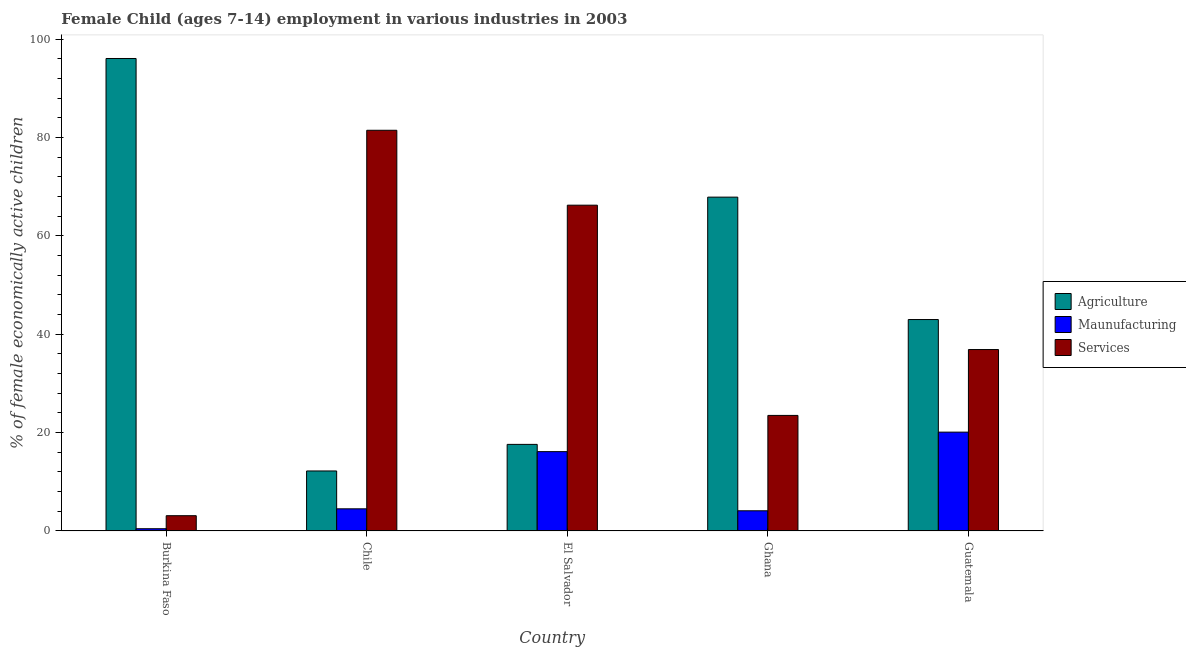How many different coloured bars are there?
Your answer should be compact. 3. Are the number of bars per tick equal to the number of legend labels?
Make the answer very short. Yes. How many bars are there on the 3rd tick from the left?
Your response must be concise. 3. How many bars are there on the 1st tick from the right?
Ensure brevity in your answer.  3. What is the label of the 1st group of bars from the left?
Provide a succinct answer. Burkina Faso. In how many cases, is the number of bars for a given country not equal to the number of legend labels?
Provide a short and direct response. 0. Across all countries, what is the maximum percentage of economically active children in manufacturing?
Your response must be concise. 20.1. In which country was the percentage of economically active children in services maximum?
Offer a very short reply. Chile. In which country was the percentage of economically active children in services minimum?
Ensure brevity in your answer.  Burkina Faso. What is the total percentage of economically active children in agriculture in the graph?
Your answer should be compact. 236.81. What is the difference between the percentage of economically active children in services in Burkina Faso and that in Ghana?
Provide a short and direct response. -20.4. What is the difference between the percentage of economically active children in manufacturing in Chile and the percentage of economically active children in services in Guatemala?
Your answer should be very brief. -32.4. What is the average percentage of economically active children in manufacturing per country?
Provide a short and direct response. 9.06. What is the difference between the percentage of economically active children in services and percentage of economically active children in agriculture in Guatemala?
Your response must be concise. -6.1. What is the ratio of the percentage of economically active children in manufacturing in Burkina Faso to that in Chile?
Offer a terse response. 0.1. Is the percentage of economically active children in services in Burkina Faso less than that in El Salvador?
Provide a short and direct response. Yes. Is the difference between the percentage of economically active children in manufacturing in El Salvador and Ghana greater than the difference between the percentage of economically active children in services in El Salvador and Ghana?
Your response must be concise. No. What is the difference between the highest and the second highest percentage of economically active children in manufacturing?
Make the answer very short. 3.97. What is the difference between the highest and the lowest percentage of economically active children in manufacturing?
Keep it short and to the point. 19.65. In how many countries, is the percentage of economically active children in services greater than the average percentage of economically active children in services taken over all countries?
Make the answer very short. 2. What does the 1st bar from the left in El Salvador represents?
Offer a very short reply. Agriculture. What does the 2nd bar from the right in Chile represents?
Ensure brevity in your answer.  Maunufacturing. Is it the case that in every country, the sum of the percentage of economically active children in agriculture and percentage of economically active children in manufacturing is greater than the percentage of economically active children in services?
Provide a succinct answer. No. How many bars are there?
Make the answer very short. 15. Are all the bars in the graph horizontal?
Your answer should be compact. No. Are the values on the major ticks of Y-axis written in scientific E-notation?
Provide a succinct answer. No. Does the graph contain any zero values?
Make the answer very short. No. Does the graph contain grids?
Give a very brief answer. No. How are the legend labels stacked?
Give a very brief answer. Vertical. What is the title of the graph?
Your answer should be very brief. Female Child (ages 7-14) employment in various industries in 2003. Does "Refusal of sex" appear as one of the legend labels in the graph?
Offer a very short reply. No. What is the label or title of the X-axis?
Offer a very short reply. Country. What is the label or title of the Y-axis?
Make the answer very short. % of female economically active children. What is the % of female economically active children in Agriculture in Burkina Faso?
Your response must be concise. 96.1. What is the % of female economically active children in Maunufacturing in Burkina Faso?
Your answer should be very brief. 0.45. What is the % of female economically active children of Agriculture in Chile?
Provide a succinct answer. 12.2. What is the % of female economically active children of Services in Chile?
Your response must be concise. 81.5. What is the % of female economically active children in Agriculture in El Salvador?
Offer a terse response. 17.61. What is the % of female economically active children of Maunufacturing in El Salvador?
Offer a very short reply. 16.13. What is the % of female economically active children of Services in El Salvador?
Provide a short and direct response. 66.26. What is the % of female economically active children of Agriculture in Ghana?
Provide a succinct answer. 67.9. What is the % of female economically active children of Agriculture in Guatemala?
Offer a terse response. 43. What is the % of female economically active children of Maunufacturing in Guatemala?
Offer a terse response. 20.1. What is the % of female economically active children in Services in Guatemala?
Your answer should be compact. 36.9. Across all countries, what is the maximum % of female economically active children in Agriculture?
Ensure brevity in your answer.  96.1. Across all countries, what is the maximum % of female economically active children of Maunufacturing?
Ensure brevity in your answer.  20.1. Across all countries, what is the maximum % of female economically active children in Services?
Provide a short and direct response. 81.5. Across all countries, what is the minimum % of female economically active children in Agriculture?
Give a very brief answer. 12.2. Across all countries, what is the minimum % of female economically active children of Maunufacturing?
Give a very brief answer. 0.45. What is the total % of female economically active children of Agriculture in the graph?
Offer a terse response. 236.81. What is the total % of female economically active children in Maunufacturing in the graph?
Give a very brief answer. 45.28. What is the total % of female economically active children in Services in the graph?
Your response must be concise. 211.26. What is the difference between the % of female economically active children of Agriculture in Burkina Faso and that in Chile?
Offer a terse response. 83.9. What is the difference between the % of female economically active children of Maunufacturing in Burkina Faso and that in Chile?
Your answer should be very brief. -4.05. What is the difference between the % of female economically active children in Services in Burkina Faso and that in Chile?
Make the answer very short. -78.4. What is the difference between the % of female economically active children of Agriculture in Burkina Faso and that in El Salvador?
Ensure brevity in your answer.  78.49. What is the difference between the % of female economically active children of Maunufacturing in Burkina Faso and that in El Salvador?
Provide a succinct answer. -15.68. What is the difference between the % of female economically active children of Services in Burkina Faso and that in El Salvador?
Your response must be concise. -63.16. What is the difference between the % of female economically active children of Agriculture in Burkina Faso and that in Ghana?
Offer a very short reply. 28.2. What is the difference between the % of female economically active children in Maunufacturing in Burkina Faso and that in Ghana?
Provide a succinct answer. -3.65. What is the difference between the % of female economically active children of Services in Burkina Faso and that in Ghana?
Your answer should be compact. -20.4. What is the difference between the % of female economically active children of Agriculture in Burkina Faso and that in Guatemala?
Offer a very short reply. 53.1. What is the difference between the % of female economically active children of Maunufacturing in Burkina Faso and that in Guatemala?
Ensure brevity in your answer.  -19.65. What is the difference between the % of female economically active children of Services in Burkina Faso and that in Guatemala?
Offer a terse response. -33.8. What is the difference between the % of female economically active children of Agriculture in Chile and that in El Salvador?
Make the answer very short. -5.41. What is the difference between the % of female economically active children of Maunufacturing in Chile and that in El Salvador?
Give a very brief answer. -11.63. What is the difference between the % of female economically active children of Services in Chile and that in El Salvador?
Ensure brevity in your answer.  15.24. What is the difference between the % of female economically active children of Agriculture in Chile and that in Ghana?
Provide a succinct answer. -55.7. What is the difference between the % of female economically active children in Maunufacturing in Chile and that in Ghana?
Offer a very short reply. 0.4. What is the difference between the % of female economically active children of Agriculture in Chile and that in Guatemala?
Provide a short and direct response. -30.8. What is the difference between the % of female economically active children in Maunufacturing in Chile and that in Guatemala?
Your response must be concise. -15.6. What is the difference between the % of female economically active children in Services in Chile and that in Guatemala?
Your answer should be very brief. 44.6. What is the difference between the % of female economically active children of Agriculture in El Salvador and that in Ghana?
Offer a terse response. -50.29. What is the difference between the % of female economically active children in Maunufacturing in El Salvador and that in Ghana?
Provide a short and direct response. 12.03. What is the difference between the % of female economically active children of Services in El Salvador and that in Ghana?
Keep it short and to the point. 42.76. What is the difference between the % of female economically active children of Agriculture in El Salvador and that in Guatemala?
Offer a very short reply. -25.39. What is the difference between the % of female economically active children of Maunufacturing in El Salvador and that in Guatemala?
Your answer should be very brief. -3.97. What is the difference between the % of female economically active children of Services in El Salvador and that in Guatemala?
Provide a short and direct response. 29.36. What is the difference between the % of female economically active children in Agriculture in Ghana and that in Guatemala?
Your answer should be compact. 24.9. What is the difference between the % of female economically active children in Agriculture in Burkina Faso and the % of female economically active children in Maunufacturing in Chile?
Ensure brevity in your answer.  91.6. What is the difference between the % of female economically active children of Maunufacturing in Burkina Faso and the % of female economically active children of Services in Chile?
Your answer should be very brief. -81.05. What is the difference between the % of female economically active children in Agriculture in Burkina Faso and the % of female economically active children in Maunufacturing in El Salvador?
Keep it short and to the point. 79.97. What is the difference between the % of female economically active children of Agriculture in Burkina Faso and the % of female economically active children of Services in El Salvador?
Your response must be concise. 29.84. What is the difference between the % of female economically active children in Maunufacturing in Burkina Faso and the % of female economically active children in Services in El Salvador?
Keep it short and to the point. -65.81. What is the difference between the % of female economically active children of Agriculture in Burkina Faso and the % of female economically active children of Maunufacturing in Ghana?
Provide a succinct answer. 92. What is the difference between the % of female economically active children of Agriculture in Burkina Faso and the % of female economically active children of Services in Ghana?
Offer a very short reply. 72.6. What is the difference between the % of female economically active children of Maunufacturing in Burkina Faso and the % of female economically active children of Services in Ghana?
Your answer should be very brief. -23.05. What is the difference between the % of female economically active children of Agriculture in Burkina Faso and the % of female economically active children of Maunufacturing in Guatemala?
Your answer should be very brief. 76. What is the difference between the % of female economically active children in Agriculture in Burkina Faso and the % of female economically active children in Services in Guatemala?
Provide a short and direct response. 59.2. What is the difference between the % of female economically active children of Maunufacturing in Burkina Faso and the % of female economically active children of Services in Guatemala?
Make the answer very short. -36.45. What is the difference between the % of female economically active children in Agriculture in Chile and the % of female economically active children in Maunufacturing in El Salvador?
Your response must be concise. -3.93. What is the difference between the % of female economically active children in Agriculture in Chile and the % of female economically active children in Services in El Salvador?
Offer a terse response. -54.06. What is the difference between the % of female economically active children in Maunufacturing in Chile and the % of female economically active children in Services in El Salvador?
Make the answer very short. -61.76. What is the difference between the % of female economically active children of Agriculture in Chile and the % of female economically active children of Services in Ghana?
Offer a terse response. -11.3. What is the difference between the % of female economically active children of Agriculture in Chile and the % of female economically active children of Services in Guatemala?
Ensure brevity in your answer.  -24.7. What is the difference between the % of female economically active children of Maunufacturing in Chile and the % of female economically active children of Services in Guatemala?
Provide a succinct answer. -32.4. What is the difference between the % of female economically active children of Agriculture in El Salvador and the % of female economically active children of Maunufacturing in Ghana?
Your response must be concise. 13.51. What is the difference between the % of female economically active children in Agriculture in El Salvador and the % of female economically active children in Services in Ghana?
Offer a very short reply. -5.89. What is the difference between the % of female economically active children in Maunufacturing in El Salvador and the % of female economically active children in Services in Ghana?
Your answer should be very brief. -7.37. What is the difference between the % of female economically active children of Agriculture in El Salvador and the % of female economically active children of Maunufacturing in Guatemala?
Provide a succinct answer. -2.49. What is the difference between the % of female economically active children in Agriculture in El Salvador and the % of female economically active children in Services in Guatemala?
Make the answer very short. -19.29. What is the difference between the % of female economically active children in Maunufacturing in El Salvador and the % of female economically active children in Services in Guatemala?
Ensure brevity in your answer.  -20.77. What is the difference between the % of female economically active children of Agriculture in Ghana and the % of female economically active children of Maunufacturing in Guatemala?
Keep it short and to the point. 47.8. What is the difference between the % of female economically active children in Agriculture in Ghana and the % of female economically active children in Services in Guatemala?
Keep it short and to the point. 31. What is the difference between the % of female economically active children in Maunufacturing in Ghana and the % of female economically active children in Services in Guatemala?
Your response must be concise. -32.8. What is the average % of female economically active children in Agriculture per country?
Make the answer very short. 47.36. What is the average % of female economically active children of Maunufacturing per country?
Ensure brevity in your answer.  9.06. What is the average % of female economically active children of Services per country?
Your answer should be compact. 42.25. What is the difference between the % of female economically active children in Agriculture and % of female economically active children in Maunufacturing in Burkina Faso?
Your answer should be compact. 95.65. What is the difference between the % of female economically active children of Agriculture and % of female economically active children of Services in Burkina Faso?
Give a very brief answer. 93. What is the difference between the % of female economically active children in Maunufacturing and % of female economically active children in Services in Burkina Faso?
Make the answer very short. -2.65. What is the difference between the % of female economically active children of Agriculture and % of female economically active children of Maunufacturing in Chile?
Make the answer very short. 7.7. What is the difference between the % of female economically active children in Agriculture and % of female economically active children in Services in Chile?
Your answer should be very brief. -69.3. What is the difference between the % of female economically active children of Maunufacturing and % of female economically active children of Services in Chile?
Offer a terse response. -77. What is the difference between the % of female economically active children in Agriculture and % of female economically active children in Maunufacturing in El Salvador?
Provide a succinct answer. 1.47. What is the difference between the % of female economically active children of Agriculture and % of female economically active children of Services in El Salvador?
Offer a very short reply. -48.66. What is the difference between the % of female economically active children of Maunufacturing and % of female economically active children of Services in El Salvador?
Make the answer very short. -50.13. What is the difference between the % of female economically active children in Agriculture and % of female economically active children in Maunufacturing in Ghana?
Make the answer very short. 63.8. What is the difference between the % of female economically active children of Agriculture and % of female economically active children of Services in Ghana?
Offer a terse response. 44.4. What is the difference between the % of female economically active children in Maunufacturing and % of female economically active children in Services in Ghana?
Keep it short and to the point. -19.4. What is the difference between the % of female economically active children of Agriculture and % of female economically active children of Maunufacturing in Guatemala?
Offer a terse response. 22.9. What is the difference between the % of female economically active children of Agriculture and % of female economically active children of Services in Guatemala?
Make the answer very short. 6.1. What is the difference between the % of female economically active children of Maunufacturing and % of female economically active children of Services in Guatemala?
Provide a short and direct response. -16.8. What is the ratio of the % of female economically active children of Agriculture in Burkina Faso to that in Chile?
Your answer should be very brief. 7.88. What is the ratio of the % of female economically active children in Maunufacturing in Burkina Faso to that in Chile?
Provide a succinct answer. 0.1. What is the ratio of the % of female economically active children in Services in Burkina Faso to that in Chile?
Provide a short and direct response. 0.04. What is the ratio of the % of female economically active children in Agriculture in Burkina Faso to that in El Salvador?
Provide a short and direct response. 5.46. What is the ratio of the % of female economically active children of Maunufacturing in Burkina Faso to that in El Salvador?
Provide a succinct answer. 0.03. What is the ratio of the % of female economically active children of Services in Burkina Faso to that in El Salvador?
Ensure brevity in your answer.  0.05. What is the ratio of the % of female economically active children of Agriculture in Burkina Faso to that in Ghana?
Keep it short and to the point. 1.42. What is the ratio of the % of female economically active children in Maunufacturing in Burkina Faso to that in Ghana?
Make the answer very short. 0.11. What is the ratio of the % of female economically active children of Services in Burkina Faso to that in Ghana?
Your answer should be very brief. 0.13. What is the ratio of the % of female economically active children of Agriculture in Burkina Faso to that in Guatemala?
Your answer should be very brief. 2.23. What is the ratio of the % of female economically active children in Maunufacturing in Burkina Faso to that in Guatemala?
Offer a terse response. 0.02. What is the ratio of the % of female economically active children of Services in Burkina Faso to that in Guatemala?
Provide a short and direct response. 0.08. What is the ratio of the % of female economically active children in Agriculture in Chile to that in El Salvador?
Provide a short and direct response. 0.69. What is the ratio of the % of female economically active children of Maunufacturing in Chile to that in El Salvador?
Offer a very short reply. 0.28. What is the ratio of the % of female economically active children of Services in Chile to that in El Salvador?
Offer a terse response. 1.23. What is the ratio of the % of female economically active children of Agriculture in Chile to that in Ghana?
Your answer should be compact. 0.18. What is the ratio of the % of female economically active children of Maunufacturing in Chile to that in Ghana?
Provide a short and direct response. 1.1. What is the ratio of the % of female economically active children in Services in Chile to that in Ghana?
Provide a short and direct response. 3.47. What is the ratio of the % of female economically active children in Agriculture in Chile to that in Guatemala?
Give a very brief answer. 0.28. What is the ratio of the % of female economically active children of Maunufacturing in Chile to that in Guatemala?
Provide a short and direct response. 0.22. What is the ratio of the % of female economically active children of Services in Chile to that in Guatemala?
Give a very brief answer. 2.21. What is the ratio of the % of female economically active children in Agriculture in El Salvador to that in Ghana?
Your response must be concise. 0.26. What is the ratio of the % of female economically active children in Maunufacturing in El Salvador to that in Ghana?
Keep it short and to the point. 3.93. What is the ratio of the % of female economically active children of Services in El Salvador to that in Ghana?
Ensure brevity in your answer.  2.82. What is the ratio of the % of female economically active children in Agriculture in El Salvador to that in Guatemala?
Give a very brief answer. 0.41. What is the ratio of the % of female economically active children in Maunufacturing in El Salvador to that in Guatemala?
Offer a terse response. 0.8. What is the ratio of the % of female economically active children of Services in El Salvador to that in Guatemala?
Give a very brief answer. 1.8. What is the ratio of the % of female economically active children of Agriculture in Ghana to that in Guatemala?
Your answer should be very brief. 1.58. What is the ratio of the % of female economically active children in Maunufacturing in Ghana to that in Guatemala?
Your response must be concise. 0.2. What is the ratio of the % of female economically active children in Services in Ghana to that in Guatemala?
Ensure brevity in your answer.  0.64. What is the difference between the highest and the second highest % of female economically active children of Agriculture?
Give a very brief answer. 28.2. What is the difference between the highest and the second highest % of female economically active children of Maunufacturing?
Your answer should be compact. 3.97. What is the difference between the highest and the second highest % of female economically active children of Services?
Give a very brief answer. 15.24. What is the difference between the highest and the lowest % of female economically active children of Agriculture?
Your response must be concise. 83.9. What is the difference between the highest and the lowest % of female economically active children of Maunufacturing?
Offer a very short reply. 19.65. What is the difference between the highest and the lowest % of female economically active children of Services?
Your answer should be very brief. 78.4. 